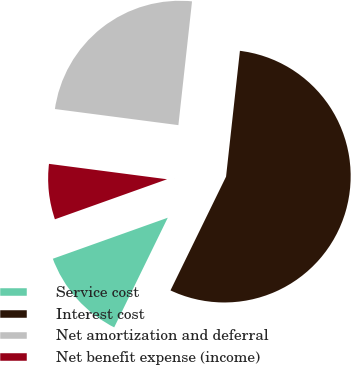<chart> <loc_0><loc_0><loc_500><loc_500><pie_chart><fcel>Service cost<fcel>Interest cost<fcel>Net amortization and deferral<fcel>Net benefit expense (income)<nl><fcel>12.31%<fcel>55.48%<fcel>24.68%<fcel>7.52%<nl></chart> 